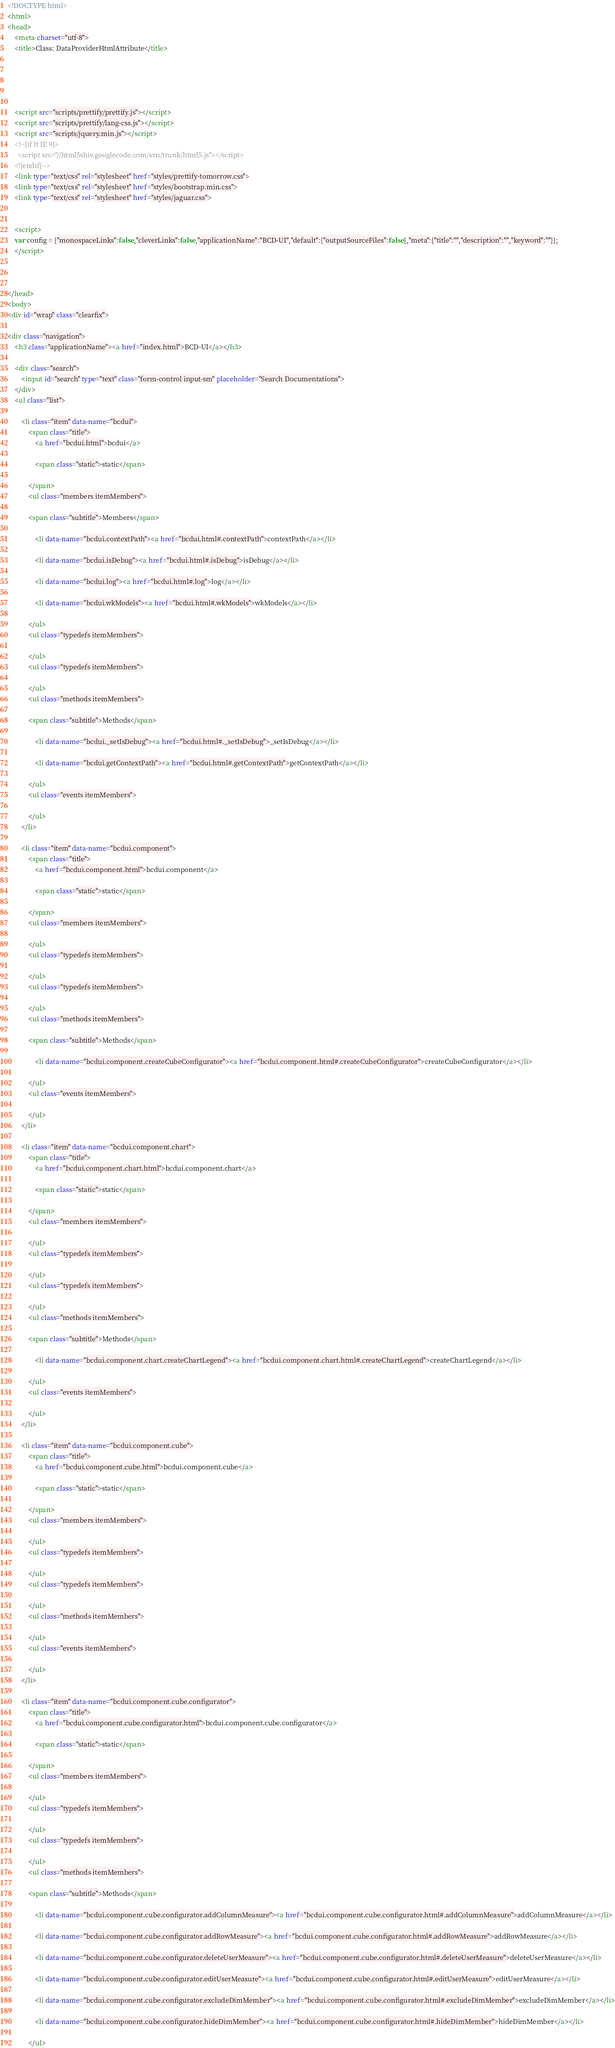<code> <loc_0><loc_0><loc_500><loc_500><_HTML_><!DOCTYPE html>
<html>
<head>
    <meta charset="utf-8">
    <title>Class: DataProviderHtmlAttribute</title>
    
    
    
    
    
    <script src="scripts/prettify/prettify.js"></script>
    <script src="scripts/prettify/lang-css.js"></script>
    <script src="scripts/jquery.min.js"></script>
    <!--[if lt IE 9]>
      <script src="//html5shiv.googlecode.com/svn/trunk/html5.js"></script>
    <![endif]-->
    <link type="text/css" rel="stylesheet" href="styles/prettify-tomorrow.css">
    <link type="text/css" rel="stylesheet" href="styles/bootstrap.min.css">
    <link type="text/css" rel="stylesheet" href="styles/jaguar.css">
    
    
    <script>
    var config = {"monospaceLinks":false,"cleverLinks":false,"applicationName":"BCD-UI","default":{"outputSourceFiles":false},"meta":{"title":"","description":"","keyword":""}};
    </script>
    

    
</head>
<body>
<div id="wrap" class="clearfix">
    
<div class="navigation">
    <h3 class="applicationName"><a href="index.html">BCD-UI</a></h3>

    <div class="search">
        <input id="search" type="text" class="form-control input-sm" placeholder="Search Documentations">
    </div>
    <ul class="list">
    
        <li class="item" data-name="bcdui">
            <span class="title">
                <a href="bcdui.html">bcdui</a>
                
                <span class="static">static</span>
                
            </span>
            <ul class="members itemMembers">
            
            <span class="subtitle">Members</span>
            
                <li data-name="bcdui.contextPath"><a href="bcdui.html#.contextPath">contextPath</a></li>
            
                <li data-name="bcdui.isDebug"><a href="bcdui.html#.isDebug">isDebug</a></li>
            
                <li data-name="bcdui.log"><a href="bcdui.html#.log">log</a></li>
            
                <li data-name="bcdui.wkModels"><a href="bcdui.html#.wkModels">wkModels</a></li>
            
            </ul>
            <ul class="typedefs itemMembers">
            
            </ul>
            <ul class="typedefs itemMembers">
            
            </ul>
            <ul class="methods itemMembers">
            
            <span class="subtitle">Methods</span>
            
                <li data-name="bcdui._setIsDebug"><a href="bcdui.html#._setIsDebug">_setIsDebug</a></li>
            
                <li data-name="bcdui.getContextPath"><a href="bcdui.html#.getContextPath">getContextPath</a></li>
            
            </ul>
            <ul class="events itemMembers">
            
            </ul>
        </li>
    
        <li class="item" data-name="bcdui.component">
            <span class="title">
                <a href="bcdui.component.html">bcdui.component</a>
                
                <span class="static">static</span>
                
            </span>
            <ul class="members itemMembers">
            
            </ul>
            <ul class="typedefs itemMembers">
            
            </ul>
            <ul class="typedefs itemMembers">
            
            </ul>
            <ul class="methods itemMembers">
            
            <span class="subtitle">Methods</span>
            
                <li data-name="bcdui.component.createCubeConfigurator"><a href="bcdui.component.html#.createCubeConfigurator">createCubeConfigurator</a></li>
            
            </ul>
            <ul class="events itemMembers">
            
            </ul>
        </li>
    
        <li class="item" data-name="bcdui.component.chart">
            <span class="title">
                <a href="bcdui.component.chart.html">bcdui.component.chart</a>
                
                <span class="static">static</span>
                
            </span>
            <ul class="members itemMembers">
            
            </ul>
            <ul class="typedefs itemMembers">
            
            </ul>
            <ul class="typedefs itemMembers">
            
            </ul>
            <ul class="methods itemMembers">
            
            <span class="subtitle">Methods</span>
            
                <li data-name="bcdui.component.chart.createChartLegend"><a href="bcdui.component.chart.html#.createChartLegend">createChartLegend</a></li>
            
            </ul>
            <ul class="events itemMembers">
            
            </ul>
        </li>
    
        <li class="item" data-name="bcdui.component.cube">
            <span class="title">
                <a href="bcdui.component.cube.html">bcdui.component.cube</a>
                
                <span class="static">static</span>
                
            </span>
            <ul class="members itemMembers">
            
            </ul>
            <ul class="typedefs itemMembers">
            
            </ul>
            <ul class="typedefs itemMembers">
            
            </ul>
            <ul class="methods itemMembers">
            
            </ul>
            <ul class="events itemMembers">
            
            </ul>
        </li>
    
        <li class="item" data-name="bcdui.component.cube.configurator">
            <span class="title">
                <a href="bcdui.component.cube.configurator.html">bcdui.component.cube.configurator</a>
                
                <span class="static">static</span>
                
            </span>
            <ul class="members itemMembers">
            
            </ul>
            <ul class="typedefs itemMembers">
            
            </ul>
            <ul class="typedefs itemMembers">
            
            </ul>
            <ul class="methods itemMembers">
            
            <span class="subtitle">Methods</span>
            
                <li data-name="bcdui.component.cube.configurator.addColumnMeasure"><a href="bcdui.component.cube.configurator.html#.addColumnMeasure">addColumnMeasure</a></li>
            
                <li data-name="bcdui.component.cube.configurator.addRowMeasure"><a href="bcdui.component.cube.configurator.html#.addRowMeasure">addRowMeasure</a></li>
            
                <li data-name="bcdui.component.cube.configurator.deleteUserMeasure"><a href="bcdui.component.cube.configurator.html#.deleteUserMeasure">deleteUserMeasure</a></li>
            
                <li data-name="bcdui.component.cube.configurator.editUserMeasure"><a href="bcdui.component.cube.configurator.html#.editUserMeasure">editUserMeasure</a></li>
            
                <li data-name="bcdui.component.cube.configurator.excludeDimMember"><a href="bcdui.component.cube.configurator.html#.excludeDimMember">excludeDimMember</a></li>
            
                <li data-name="bcdui.component.cube.configurator.hideDimMember"><a href="bcdui.component.cube.configurator.html#.hideDimMember">hideDimMember</a></li>
            
            </ul></code> 